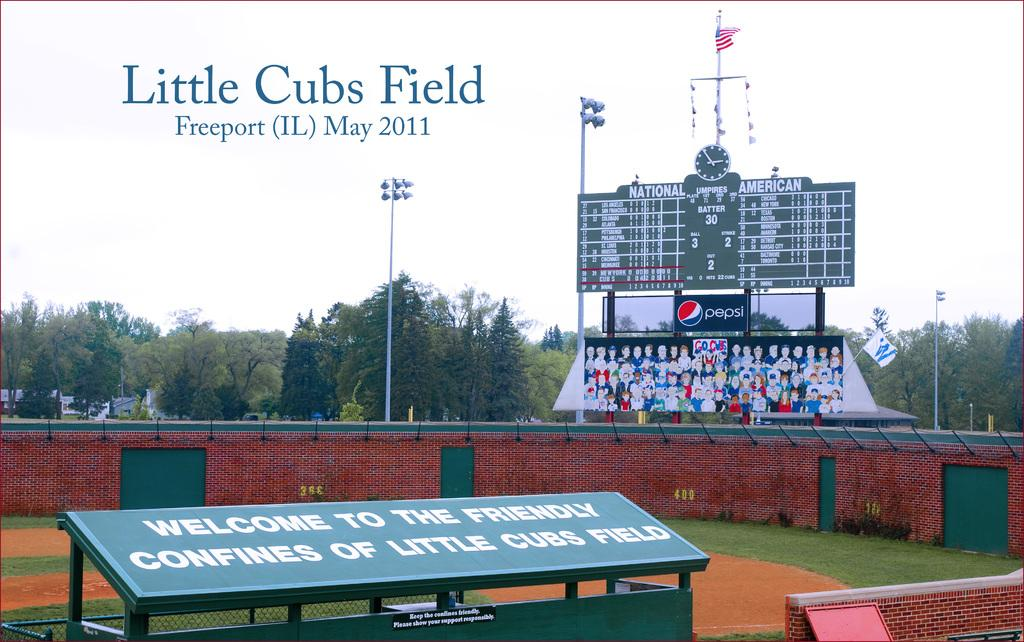What objects can be seen in the image that are made of wood or a similar material? There are boards in the image. What color is the wall in the image? There is a red-colored wall in the image. What structures are present in the image that provide support or stability? There are poles in the image. What type of illumination is visible in the image? There are lights in the image. What symbol or emblem can be seen in the image? There is a flag in the image. What time-keeping device is present in the image? There is a clock in the image. What type of natural vegetation is visible in the image? There are trees in the image. What type of markings or symbols are present in the image? There is writing in the image. Can you see the pot boiling steam in the image? There is no pot or steam present in the image. How does the flag move in the image? The flag does not move in the image; it is stationary. 